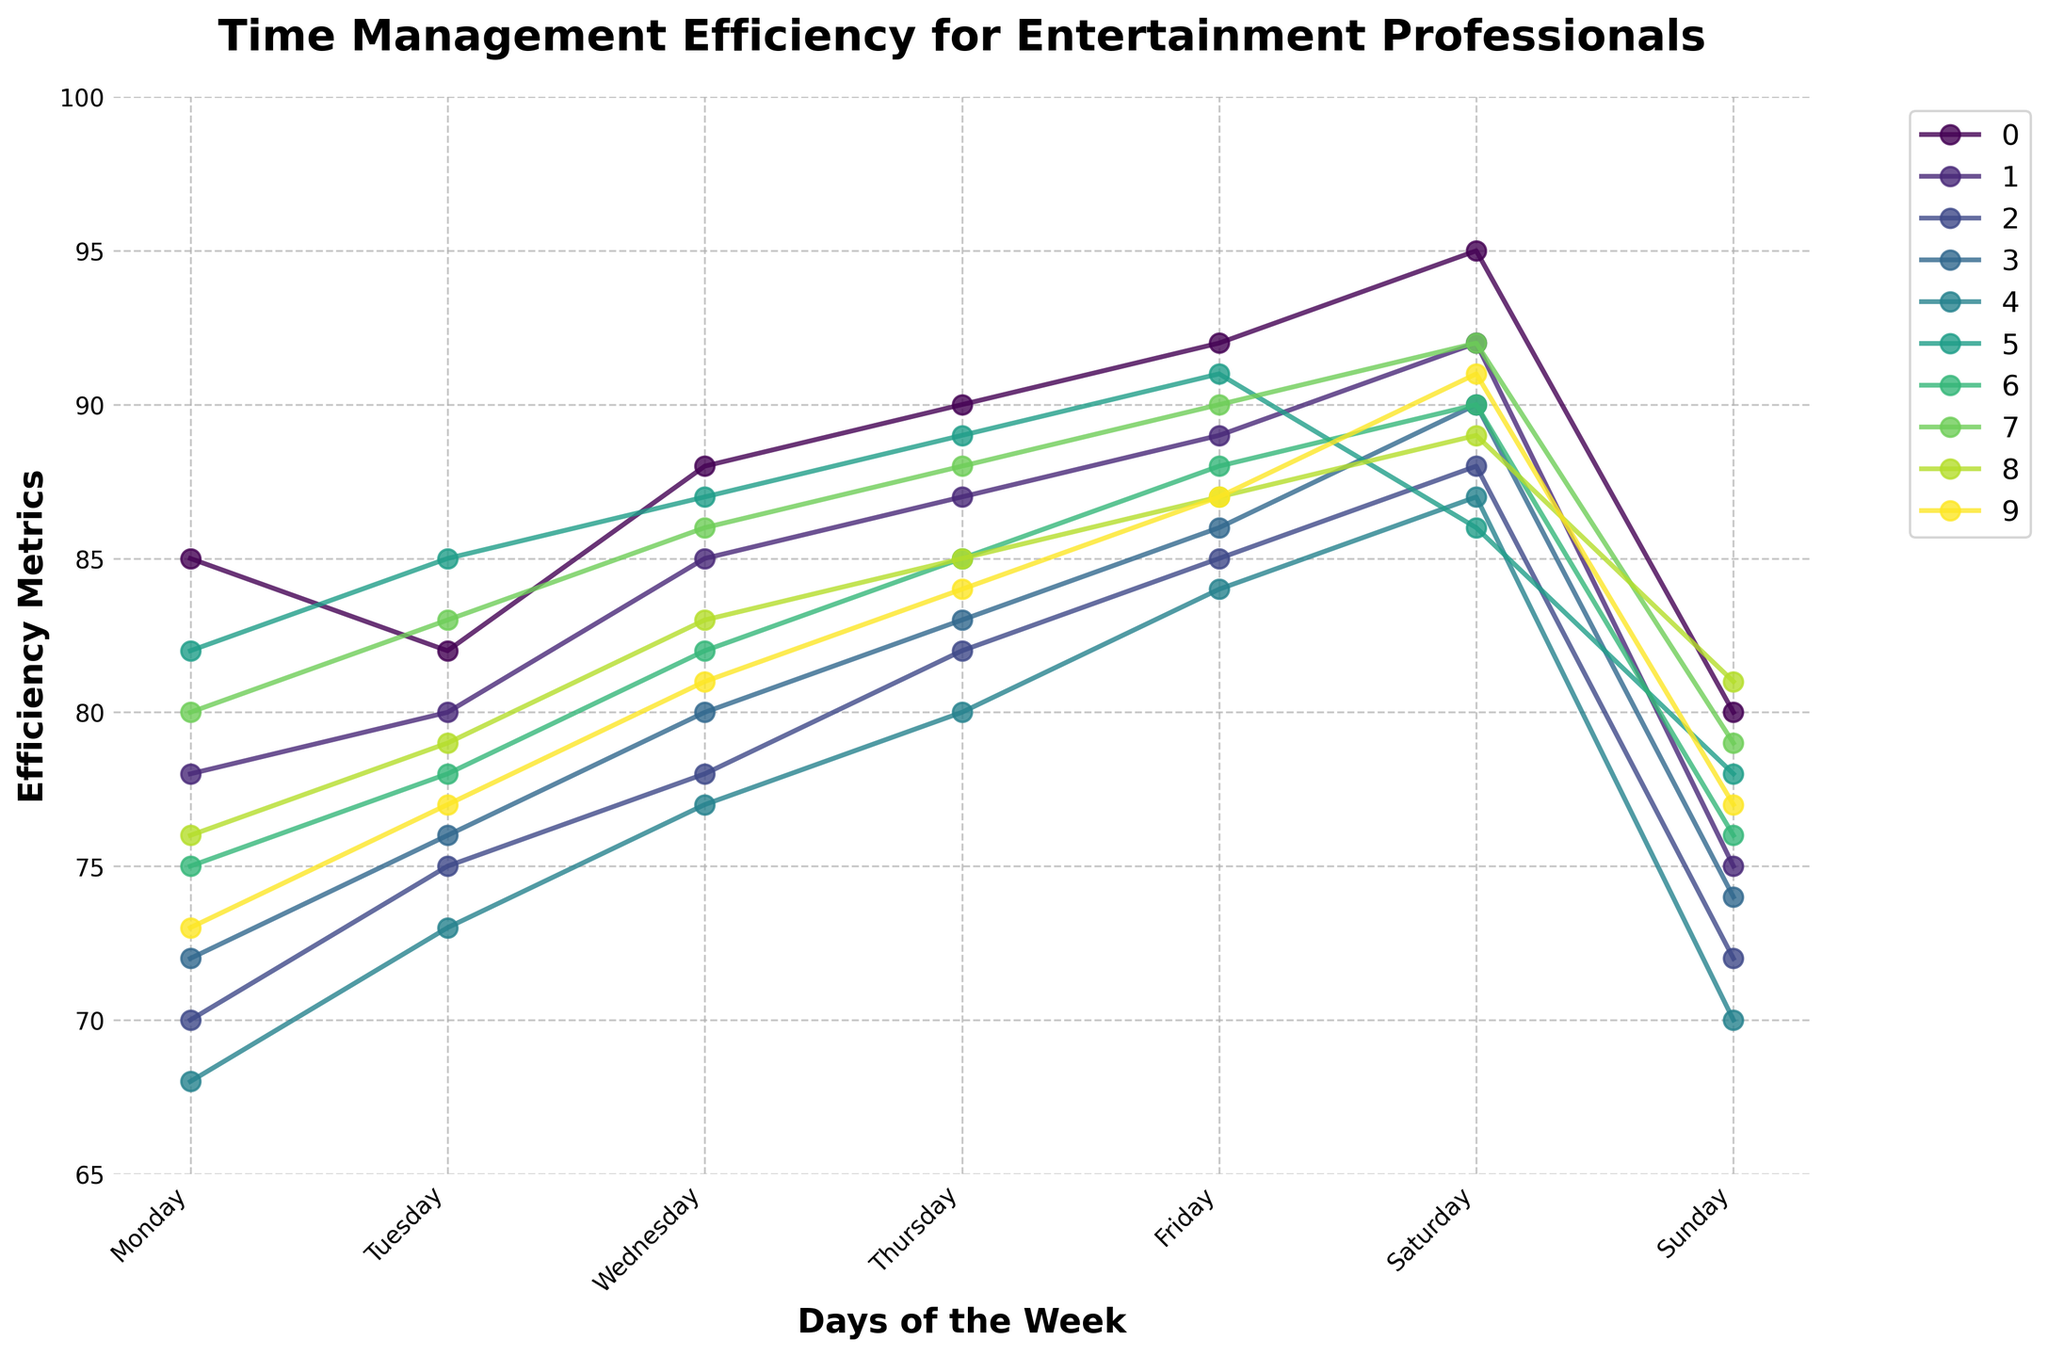Which role has the highest efficiency on Friday? Look for the point corresponding to Friday on the x-axis and compare the y-axis values for each role. Tour Manager has the highest value at 92.
Answer: Tour Manager On which day does the Backup Singer have the lowest efficiency? Identify the points for Backup Singer across all days and find the one with the lowest y-axis value. The lowest value is 70 on Monday.
Answer: Monday How does the efficiency of a Tour Manager change from Monday to Tuesday? Locate the values for the Tour Manager on Monday (85) and Tuesday (82), and calculate the difference: 85 - 82 = 3. The efficiency decreases by 3 points.
Answer: Decreases by 3 points Which two roles have identical efficiency metrics on Tuesday? Locate the value on the y-axis for Tuesday for each role and identify any two roles with the same value. Both Sound Engineer and Stylist show a value of 78.
Answer: Sound Engineer and Stylist What is the average efficiency of the Choreographer over the weekend (Saturday and Sunday)? Identify the values for Saturday (87) and Sunday (70) for the Choreographer. Calculate the average: (87 + 70) / 2 = 78.5.
Answer: 78.5 Which role shows the most consistent efficiency metrics throughout the week? Observe the trend lines for each role and identify which one has the least fluctuation. The Tour Manager’s efficiency fluctuates the least as the values remain close to each other throughout the week.
Answer: Tour Manager On which day does the Sound Engineer's efficiency first surpass 85? Locate the first day where the y-axis value for the Sound Engineer exceeds 85. This occurs on Wednesday with a value of 85.
Answer: Wednesday Between the Lighting Technician and the Venue Coordinator, who has higher efficiency on Saturday? Compare the y-axis values for Saturday for both roles. The Lighting Technician has a value of 90, while the Venue Coordinator has 91.
Answer: Venue Coordinator Which role has a higher efficiency on Friday compared to Sunday? Compare values for Friday and Sunday for each role and identify which roles have a higher value on Friday. Tour Manager (92 > 80) has higher efficiency on Friday compared to Sunday.
Answer: Tour Manager 